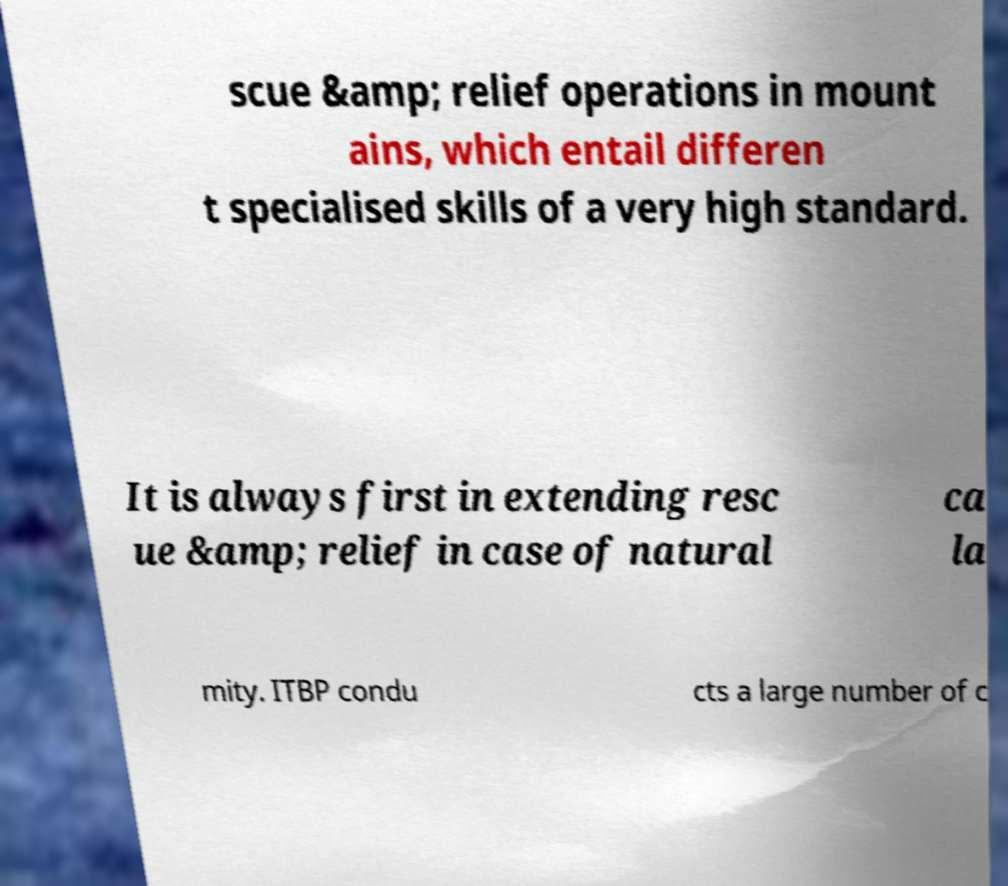Please read and relay the text visible in this image. What does it say? scue &amp; relief operations in mount ains, which entail differen t specialised skills of a very high standard. It is always first in extending resc ue &amp; relief in case of natural ca la mity. ITBP condu cts a large number of c 